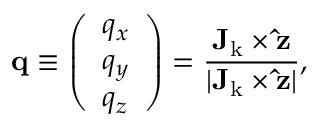<formula> <loc_0><loc_0><loc_500><loc_500>q \equiv \left ( \begin{array} { l } { q _ { x } } \\ { q _ { y } } \\ { q _ { z } } \end{array} \right ) = \frac { { J _ { k } } \times \hat { z } } { | { J _ { k } } \times \hat { z } | } ,</formula> 